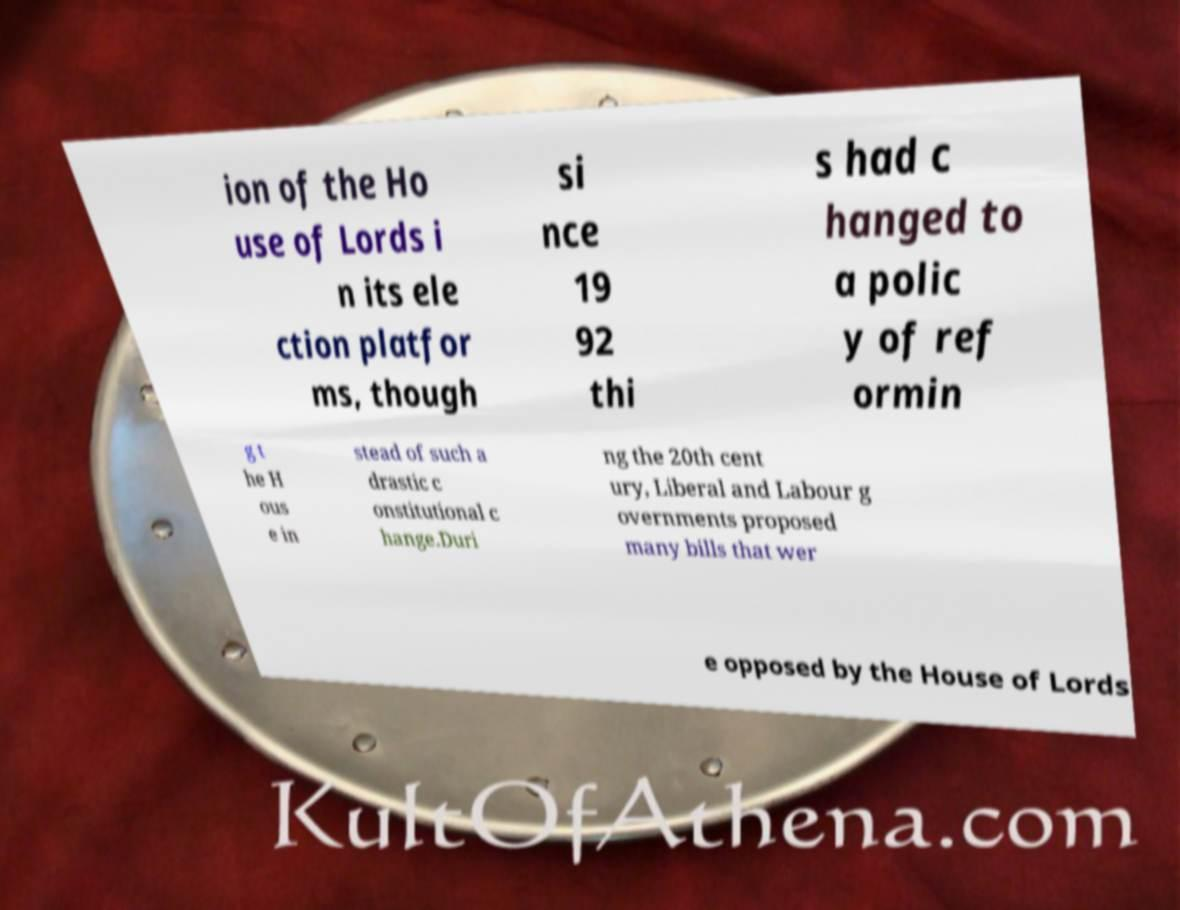I need the written content from this picture converted into text. Can you do that? ion of the Ho use of Lords i n its ele ction platfor ms, though si nce 19 92 thi s had c hanged to a polic y of ref ormin g t he H ous e in stead of such a drastic c onstitutional c hange.Duri ng the 20th cent ury, Liberal and Labour g overnments proposed many bills that wer e opposed by the House of Lords 